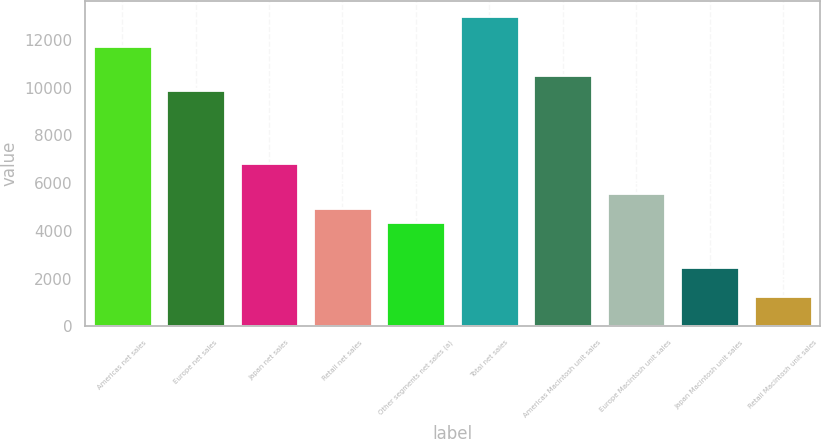<chart> <loc_0><loc_0><loc_500><loc_500><bar_chart><fcel>Americas net sales<fcel>Europe net sales<fcel>Japan net sales<fcel>Retail net sales<fcel>Other segments net sales (a)<fcel>Total net sales<fcel>Americas Macintosh unit sales<fcel>Europe Macintosh unit sales<fcel>Japan Macintosh unit sales<fcel>Retail Macintosh unit sales<nl><fcel>11760.9<fcel>9909.6<fcel>6824.1<fcel>4972.8<fcel>4355.7<fcel>12995.1<fcel>10526.7<fcel>5589.9<fcel>2504.4<fcel>1270.2<nl></chart> 